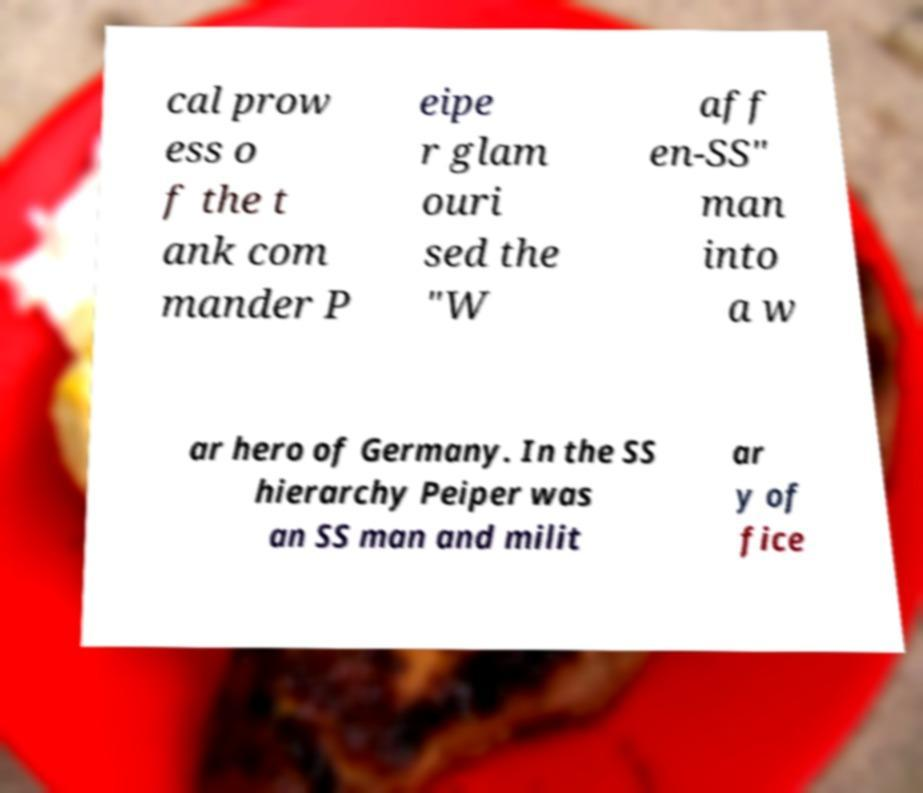Could you extract and type out the text from this image? cal prow ess o f the t ank com mander P eipe r glam ouri sed the "W aff en-SS" man into a w ar hero of Germany. In the SS hierarchy Peiper was an SS man and milit ar y of fice 